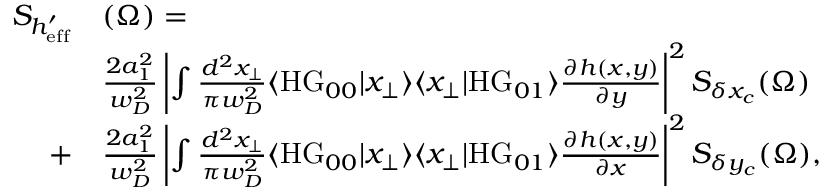<formula> <loc_0><loc_0><loc_500><loc_500>\begin{array} { r l } { S _ { h _ { e f f } ^ { \prime } } } & { ( \Omega ) = } \\ & { \frac { 2 a _ { 1 } ^ { 2 } } { w _ { D } ^ { 2 } } \left | \int \frac { d ^ { 2 } x _ { \perp } } { \pi w _ { D } ^ { 2 } } \langle H G _ { 0 0 } | x _ { \perp } \rangle \langle x _ { \perp } | H G _ { 0 1 } \rangle \frac { \partial h ( x , y ) } { \partial y } \right | ^ { 2 } S _ { \delta x _ { c } } ( \Omega ) } \\ { + } & { \frac { 2 a _ { 1 } ^ { 2 } } { w _ { D } ^ { 2 } } \left | \int \frac { d ^ { 2 } x _ { \perp } } { \pi w _ { D } ^ { 2 } } \langle H G _ { 0 0 } | x _ { \perp } \rangle \langle x _ { \perp } | H G _ { 0 1 } \rangle \frac { \partial h ( x , y ) } { \partial x } \right | ^ { 2 } S _ { \delta y _ { c } } ( \Omega ) , } \end{array}</formula> 